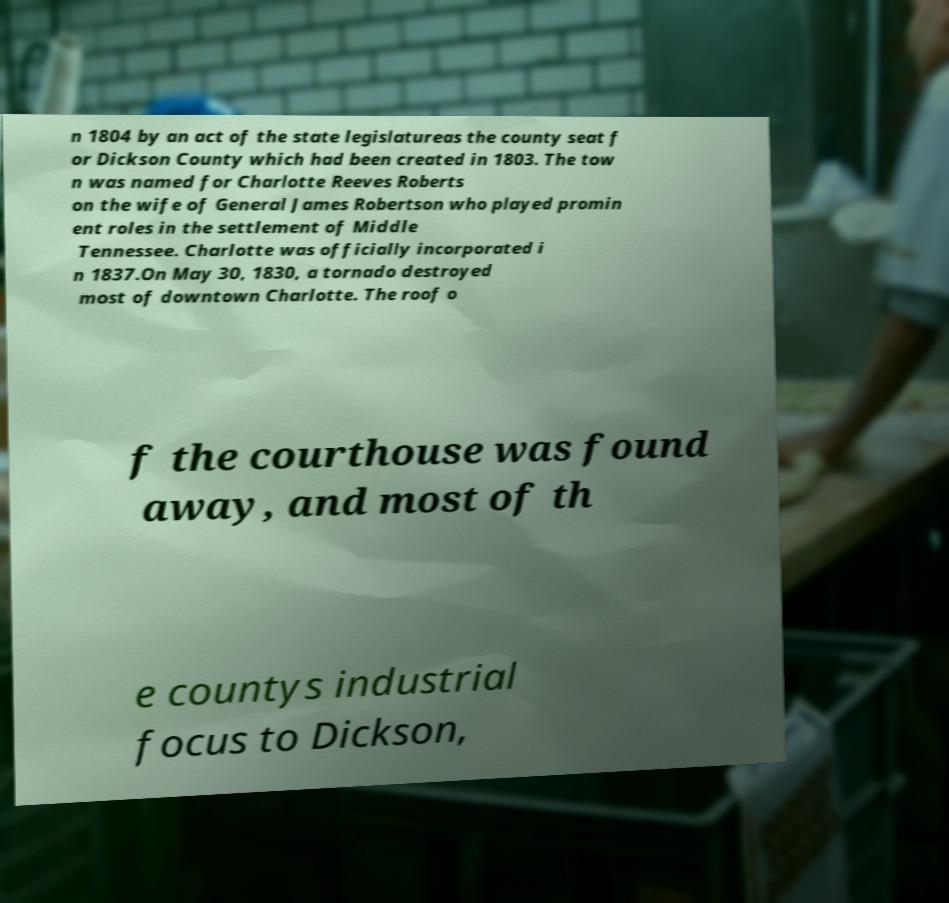Could you extract and type out the text from this image? n 1804 by an act of the state legislatureas the county seat f or Dickson County which had been created in 1803. The tow n was named for Charlotte Reeves Roberts on the wife of General James Robertson who played promin ent roles in the settlement of Middle Tennessee. Charlotte was officially incorporated i n 1837.On May 30, 1830, a tornado destroyed most of downtown Charlotte. The roof o f the courthouse was found away, and most of th e countys industrial focus to Dickson, 